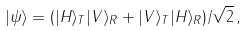Convert formula to latex. <formula><loc_0><loc_0><loc_500><loc_500>| \psi \rangle = ( | H \rangle _ { T } | V \rangle _ { R } + | V \rangle _ { T } | H \rangle _ { R } ) / \sqrt { 2 } \, ,</formula> 